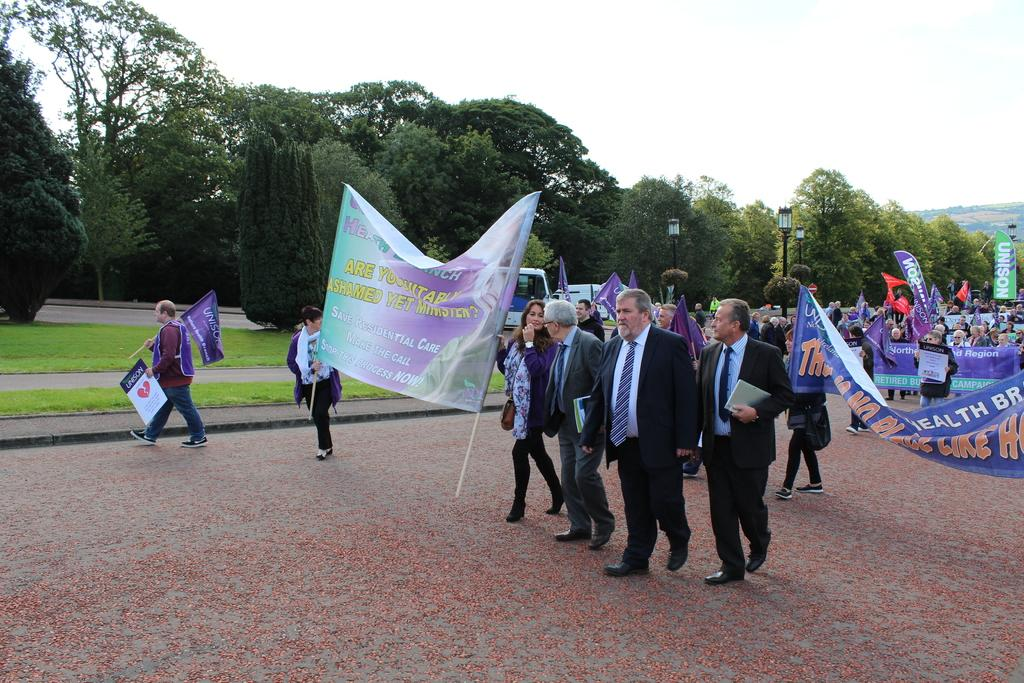Who or what can be seen in the image? There are people in the image. What else is present in the image besides people? There are flags, banners, trees, street lamps, and the sky visible in the image. Can you describe the flags and banners in the image? The flags and banners are likely used for decoration or to convey a message. What type of lighting is provided in the image? Street lamps provide lighting in the image. What word is being used by the passenger in the image? There is no passenger present in the image, and therefore no one is using any words. 